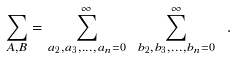Convert formula to latex. <formula><loc_0><loc_0><loc_500><loc_500>\sum _ { A , B } = \sum _ { a _ { 2 } , a _ { 3 } , \dots , a _ { n } = 0 } ^ { \infty } \ \sum _ { b _ { 2 } , b _ { 3 } , \dots , b _ { n } = 0 } ^ { \infty } \ .</formula> 